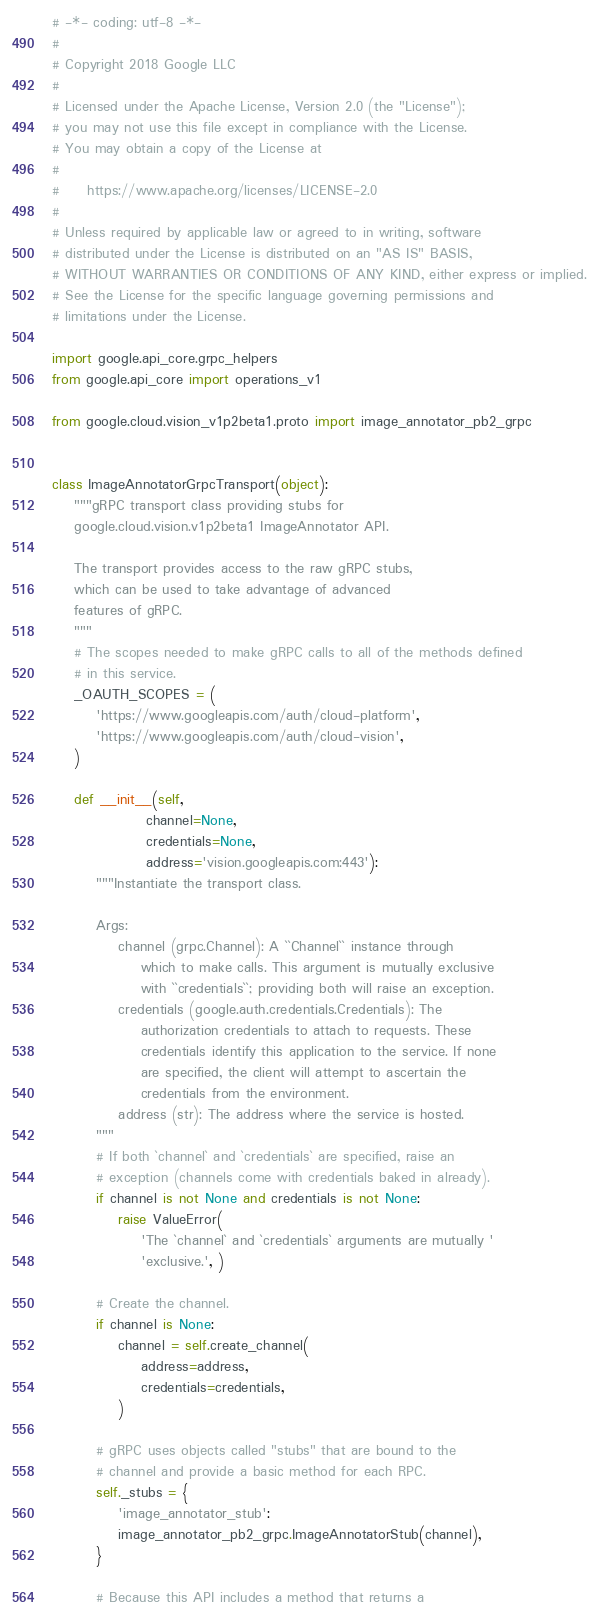<code> <loc_0><loc_0><loc_500><loc_500><_Python_># -*- coding: utf-8 -*-
#
# Copyright 2018 Google LLC
#
# Licensed under the Apache License, Version 2.0 (the "License");
# you may not use this file except in compliance with the License.
# You may obtain a copy of the License at
#
#     https://www.apache.org/licenses/LICENSE-2.0
#
# Unless required by applicable law or agreed to in writing, software
# distributed under the License is distributed on an "AS IS" BASIS,
# WITHOUT WARRANTIES OR CONDITIONS OF ANY KIND, either express or implied.
# See the License for the specific language governing permissions and
# limitations under the License.

import google.api_core.grpc_helpers
from google.api_core import operations_v1

from google.cloud.vision_v1p2beta1.proto import image_annotator_pb2_grpc


class ImageAnnotatorGrpcTransport(object):
    """gRPC transport class providing stubs for
    google.cloud.vision.v1p2beta1 ImageAnnotator API.

    The transport provides access to the raw gRPC stubs,
    which can be used to take advantage of advanced
    features of gRPC.
    """
    # The scopes needed to make gRPC calls to all of the methods defined
    # in this service.
    _OAUTH_SCOPES = (
        'https://www.googleapis.com/auth/cloud-platform',
        'https://www.googleapis.com/auth/cloud-vision',
    )

    def __init__(self,
                 channel=None,
                 credentials=None,
                 address='vision.googleapis.com:443'):
        """Instantiate the transport class.

        Args:
            channel (grpc.Channel): A ``Channel`` instance through
                which to make calls. This argument is mutually exclusive
                with ``credentials``; providing both will raise an exception.
            credentials (google.auth.credentials.Credentials): The
                authorization credentials to attach to requests. These
                credentials identify this application to the service. If none
                are specified, the client will attempt to ascertain the
                credentials from the environment.
            address (str): The address where the service is hosted.
        """
        # If both `channel` and `credentials` are specified, raise an
        # exception (channels come with credentials baked in already).
        if channel is not None and credentials is not None:
            raise ValueError(
                'The `channel` and `credentials` arguments are mutually '
                'exclusive.', )

        # Create the channel.
        if channel is None:
            channel = self.create_channel(
                address=address,
                credentials=credentials,
            )

        # gRPC uses objects called "stubs" that are bound to the
        # channel and provide a basic method for each RPC.
        self._stubs = {
            'image_annotator_stub':
            image_annotator_pb2_grpc.ImageAnnotatorStub(channel),
        }

        # Because this API includes a method that returns a</code> 